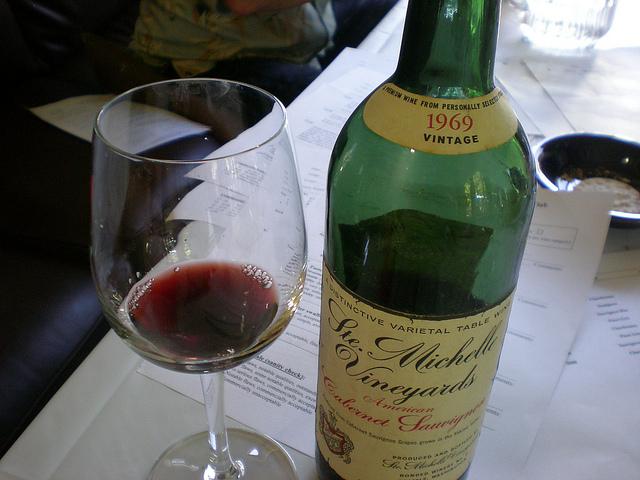Are both bottles open?
Concise answer only. Yes. How many glasses can be seen?
Give a very brief answer. 1. How many wine glasses?
Be succinct. 1. What types of wine are shown?
Concise answer only. Red. How many bottles are there?
Keep it brief. 1. Is this man getting ready to sample red or white wine?
Write a very short answer. Red. Is the wine glass empty?
Keep it brief. No. Is this a white wine?
Quick response, please. No. How many glasses are on the table?
Write a very short answer. 2. Is the bottle empty?
Quick response, please. No. Did you try this wine?
Short answer required. No. What year is on this bottle?
Concise answer only. 1969. What region is this wine from?
Quick response, please. France. 